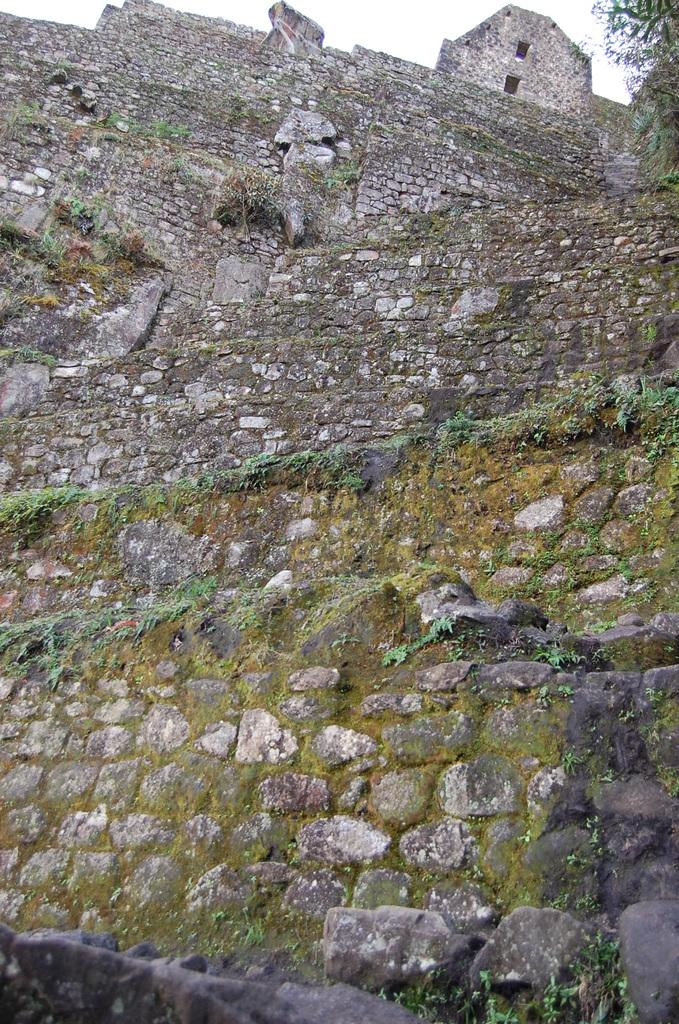What type of wall is depicted in the image? The image contains a wall made up of rocks. How tall is the wall? The wall is very tall. Are there any plants growing on the wall? Yes, there are small plants grown in the wall. What can be seen to the right of the wall? There is a tree to the right of the wall. What is visible at the top of the image? The sky is visible at the top of the image. What type of drum is being played by the instrument in the image? There is no drum or instrument present in the image; it features a rock wall with small plants and a tree. 